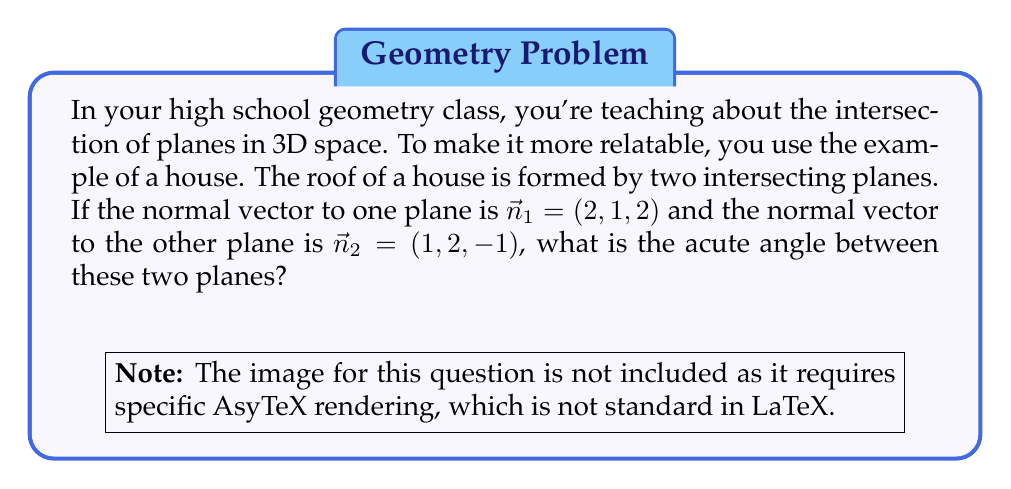Show me your answer to this math problem. To find the angle between two planes, we can use the angle between their normal vectors. The angle between two vectors can be calculated using the dot product formula:

$$\cos \theta = \frac{\vec{n}_1 \cdot \vec{n}_2}{|\vec{n}_1| |\vec{n}_2|}$$

Let's solve this step by step:

1) First, calculate the dot product $\vec{n}_1 \cdot \vec{n}_2$:
   $\vec{n}_1 \cdot \vec{n}_2 = (2)(1) + (1)(2) + (2)(-1) = 2 + 2 - 2 = 2$

2) Calculate the magnitudes of the vectors:
   $|\vec{n}_1| = \sqrt{2^2 + 1^2 + 2^2} = \sqrt{9} = 3$
   $|\vec{n}_2| = \sqrt{1^2 + 2^2 + (-1)^2} = \sqrt{6}$

3) Substitute these values into the formula:
   $$\cos \theta = \frac{2}{3\sqrt{6}}$$

4) To find $\theta$, we need to take the inverse cosine (arccos) of both sides:
   $$\theta = \arccos(\frac{2}{3\sqrt{6}})$$

5) Using a calculator, we can evaluate this:
   $$\theta \approx 1.3181 \text{ radians}$$

6) Convert to degrees:
   $$\theta \approx 75.52°$$

This is the acute angle between the planes. Note that there would also be an obtuse angle of 180° - 75.52° = 104.48°, but the question asks for the acute angle.
Answer: The acute angle between the two planes is approximately 75.52°. 